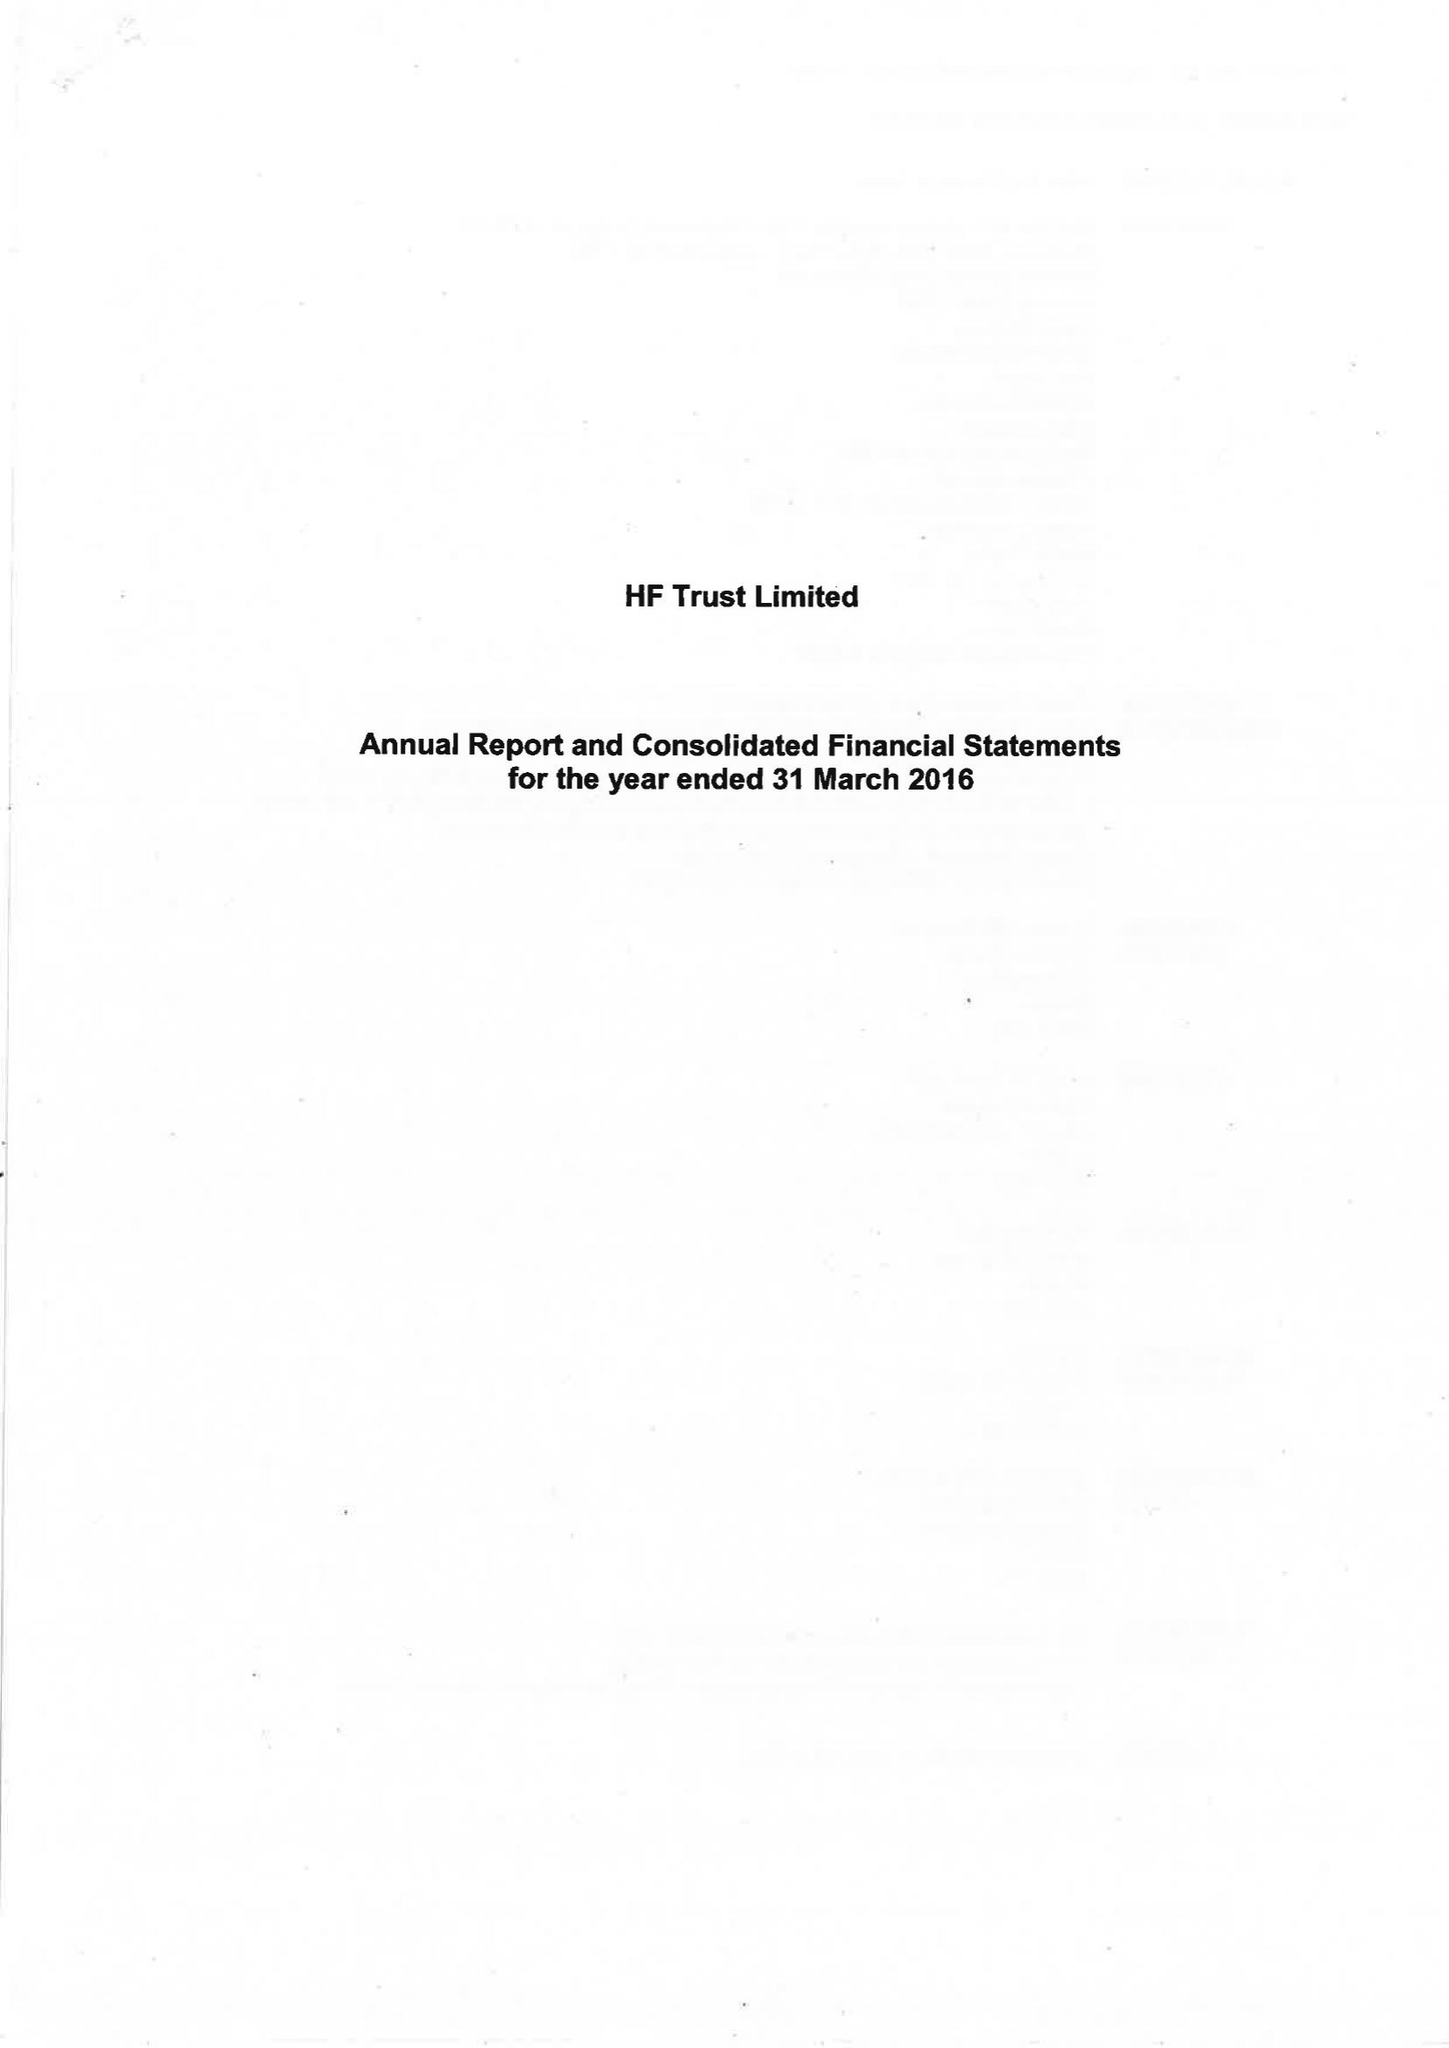What is the value for the report_date?
Answer the question using a single word or phrase. 2016-03-31 